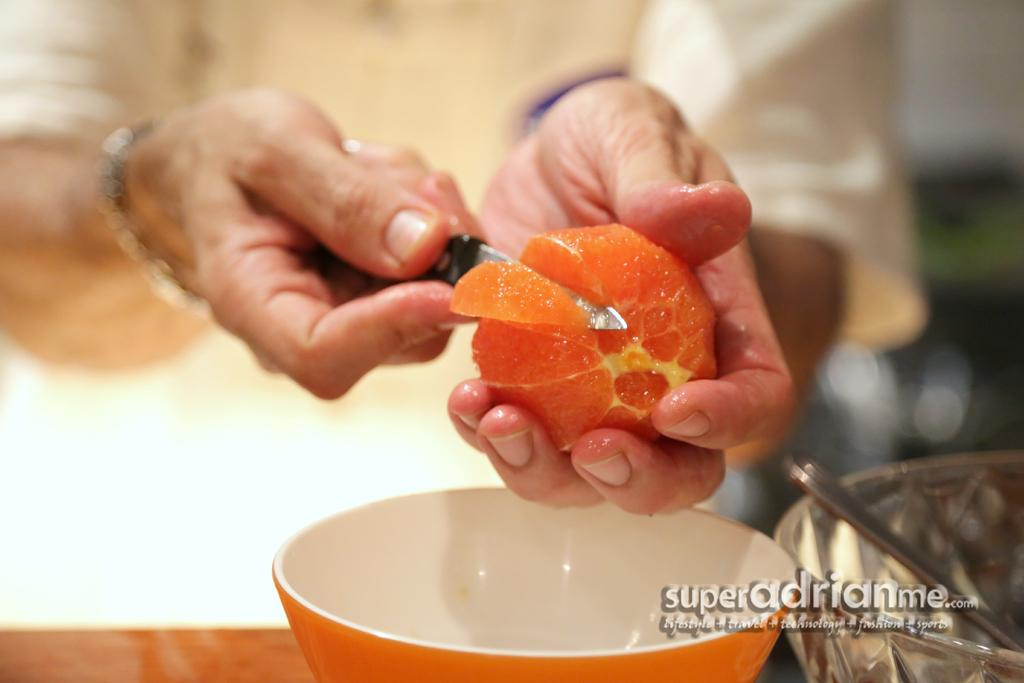What is the person in the image doing? The person is cutting fruit. What tool is the person using to cut the fruit? The person is using a knife. What can be seen in the image besides the person and the knife? There are bowls visible in the image. What type of space-themed note is the person holding in the image? There is no space-themed note present in the image. 